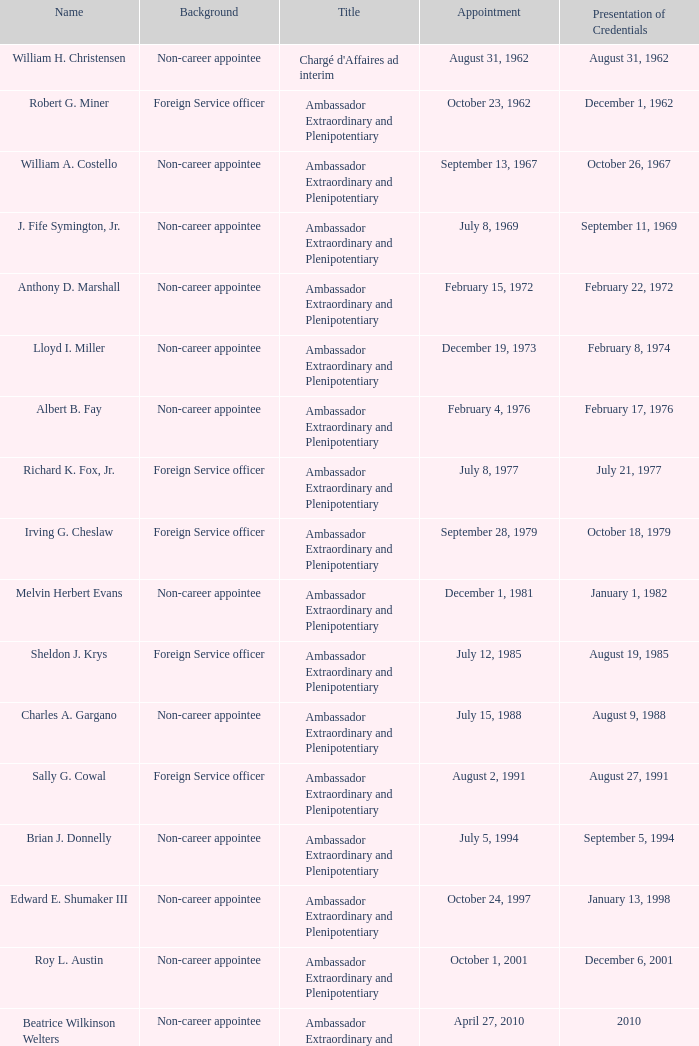When did robert g. miner submit his qualifications? December 1, 1962. Help me parse the entirety of this table. {'header': ['Name', 'Background', 'Title', 'Appointment', 'Presentation of Credentials'], 'rows': [['William H. Christensen', 'Non-career appointee', "Chargé d'Affaires ad interim", 'August 31, 1962', 'August 31, 1962'], ['Robert G. Miner', 'Foreign Service officer', 'Ambassador Extraordinary and Plenipotentiary', 'October 23, 1962', 'December 1, 1962'], ['William A. Costello', 'Non-career appointee', 'Ambassador Extraordinary and Plenipotentiary', 'September 13, 1967', 'October 26, 1967'], ['J. Fife Symington, Jr.', 'Non-career appointee', 'Ambassador Extraordinary and Plenipotentiary', 'July 8, 1969', 'September 11, 1969'], ['Anthony D. Marshall', 'Non-career appointee', 'Ambassador Extraordinary and Plenipotentiary', 'February 15, 1972', 'February 22, 1972'], ['Lloyd I. Miller', 'Non-career appointee', 'Ambassador Extraordinary and Plenipotentiary', 'December 19, 1973', 'February 8, 1974'], ['Albert B. Fay', 'Non-career appointee', 'Ambassador Extraordinary and Plenipotentiary', 'February 4, 1976', 'February 17, 1976'], ['Richard K. Fox, Jr.', 'Foreign Service officer', 'Ambassador Extraordinary and Plenipotentiary', 'July 8, 1977', 'July 21, 1977'], ['Irving G. Cheslaw', 'Foreign Service officer', 'Ambassador Extraordinary and Plenipotentiary', 'September 28, 1979', 'October 18, 1979'], ['Melvin Herbert Evans', 'Non-career appointee', 'Ambassador Extraordinary and Plenipotentiary', 'December 1, 1981', 'January 1, 1982'], ['Sheldon J. Krys', 'Foreign Service officer', 'Ambassador Extraordinary and Plenipotentiary', 'July 12, 1985', 'August 19, 1985'], ['Charles A. Gargano', 'Non-career appointee', 'Ambassador Extraordinary and Plenipotentiary', 'July 15, 1988', 'August 9, 1988'], ['Sally G. Cowal', 'Foreign Service officer', 'Ambassador Extraordinary and Plenipotentiary', 'August 2, 1991', 'August 27, 1991'], ['Brian J. Donnelly', 'Non-career appointee', 'Ambassador Extraordinary and Plenipotentiary', 'July 5, 1994', 'September 5, 1994'], ['Edward E. Shumaker III', 'Non-career appointee', 'Ambassador Extraordinary and Plenipotentiary', 'October 24, 1997', 'January 13, 1998'], ['Roy L. Austin', 'Non-career appointee', 'Ambassador Extraordinary and Plenipotentiary', 'October 1, 2001', 'December 6, 2001'], ['Beatrice Wilkinson Welters', 'Non-career appointee', 'Ambassador Extraordinary and Plenipotentiary', 'April 27, 2010', '2010'], ['Margaret B. Diop', 'Foreign Service officer', "Chargé d'Affaires ad interim", 'October 2012', 'Unknown']]} 